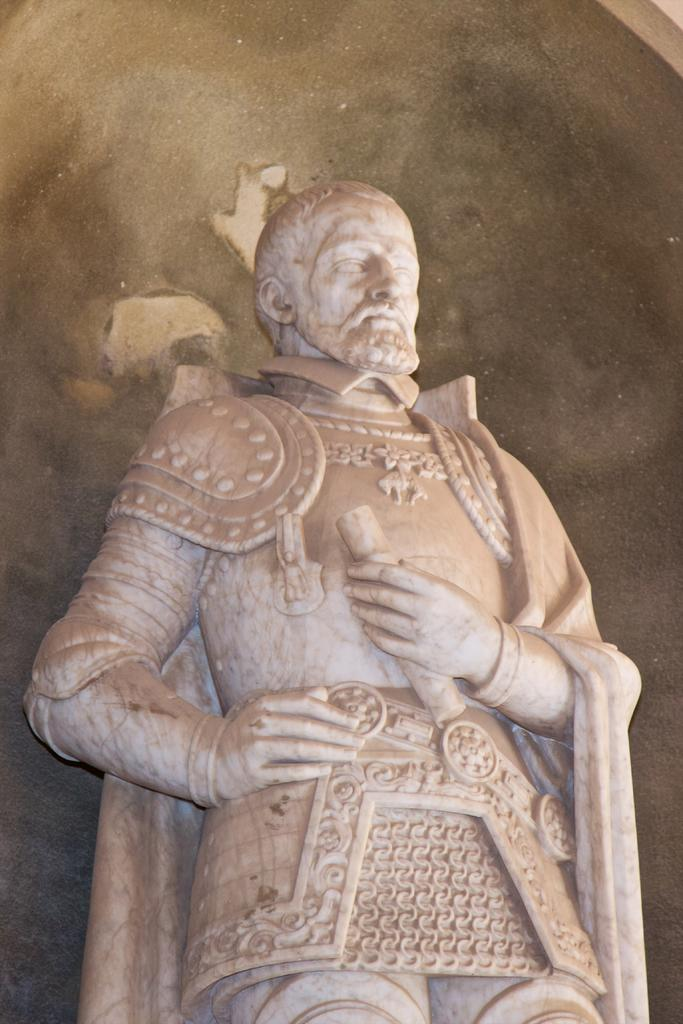What is the main subject in the middle of the image? There is a statue in the middle of the image. What can be seen in the background of the image? The background of the image appears to be black. Is there a veil covering the statue in the image? There is no mention of a veil in the provided facts, and it cannot be determined from the image whether a veil is present or not. How many worms can be seen crawling on the statue in the image? There are no worms present in the image; the statue is the only subject mentioned in the provided facts. 